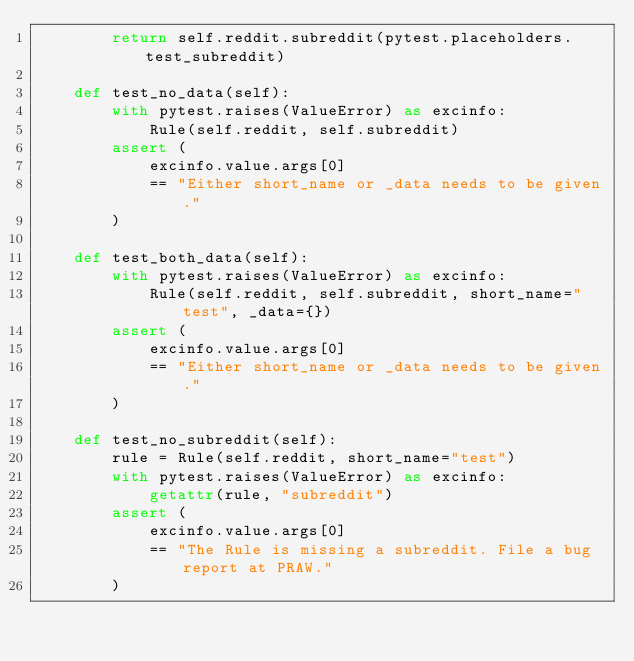<code> <loc_0><loc_0><loc_500><loc_500><_Python_>        return self.reddit.subreddit(pytest.placeholders.test_subreddit)

    def test_no_data(self):
        with pytest.raises(ValueError) as excinfo:
            Rule(self.reddit, self.subreddit)
        assert (
            excinfo.value.args[0]
            == "Either short_name or _data needs to be given."
        )

    def test_both_data(self):
        with pytest.raises(ValueError) as excinfo:
            Rule(self.reddit, self.subreddit, short_name="test", _data={})
        assert (
            excinfo.value.args[0]
            == "Either short_name or _data needs to be given."
        )

    def test_no_subreddit(self):
        rule = Rule(self.reddit, short_name="test")
        with pytest.raises(ValueError) as excinfo:
            getattr(rule, "subreddit")
        assert (
            excinfo.value.args[0]
            == "The Rule is missing a subreddit. File a bug report at PRAW."
        )
</code> 